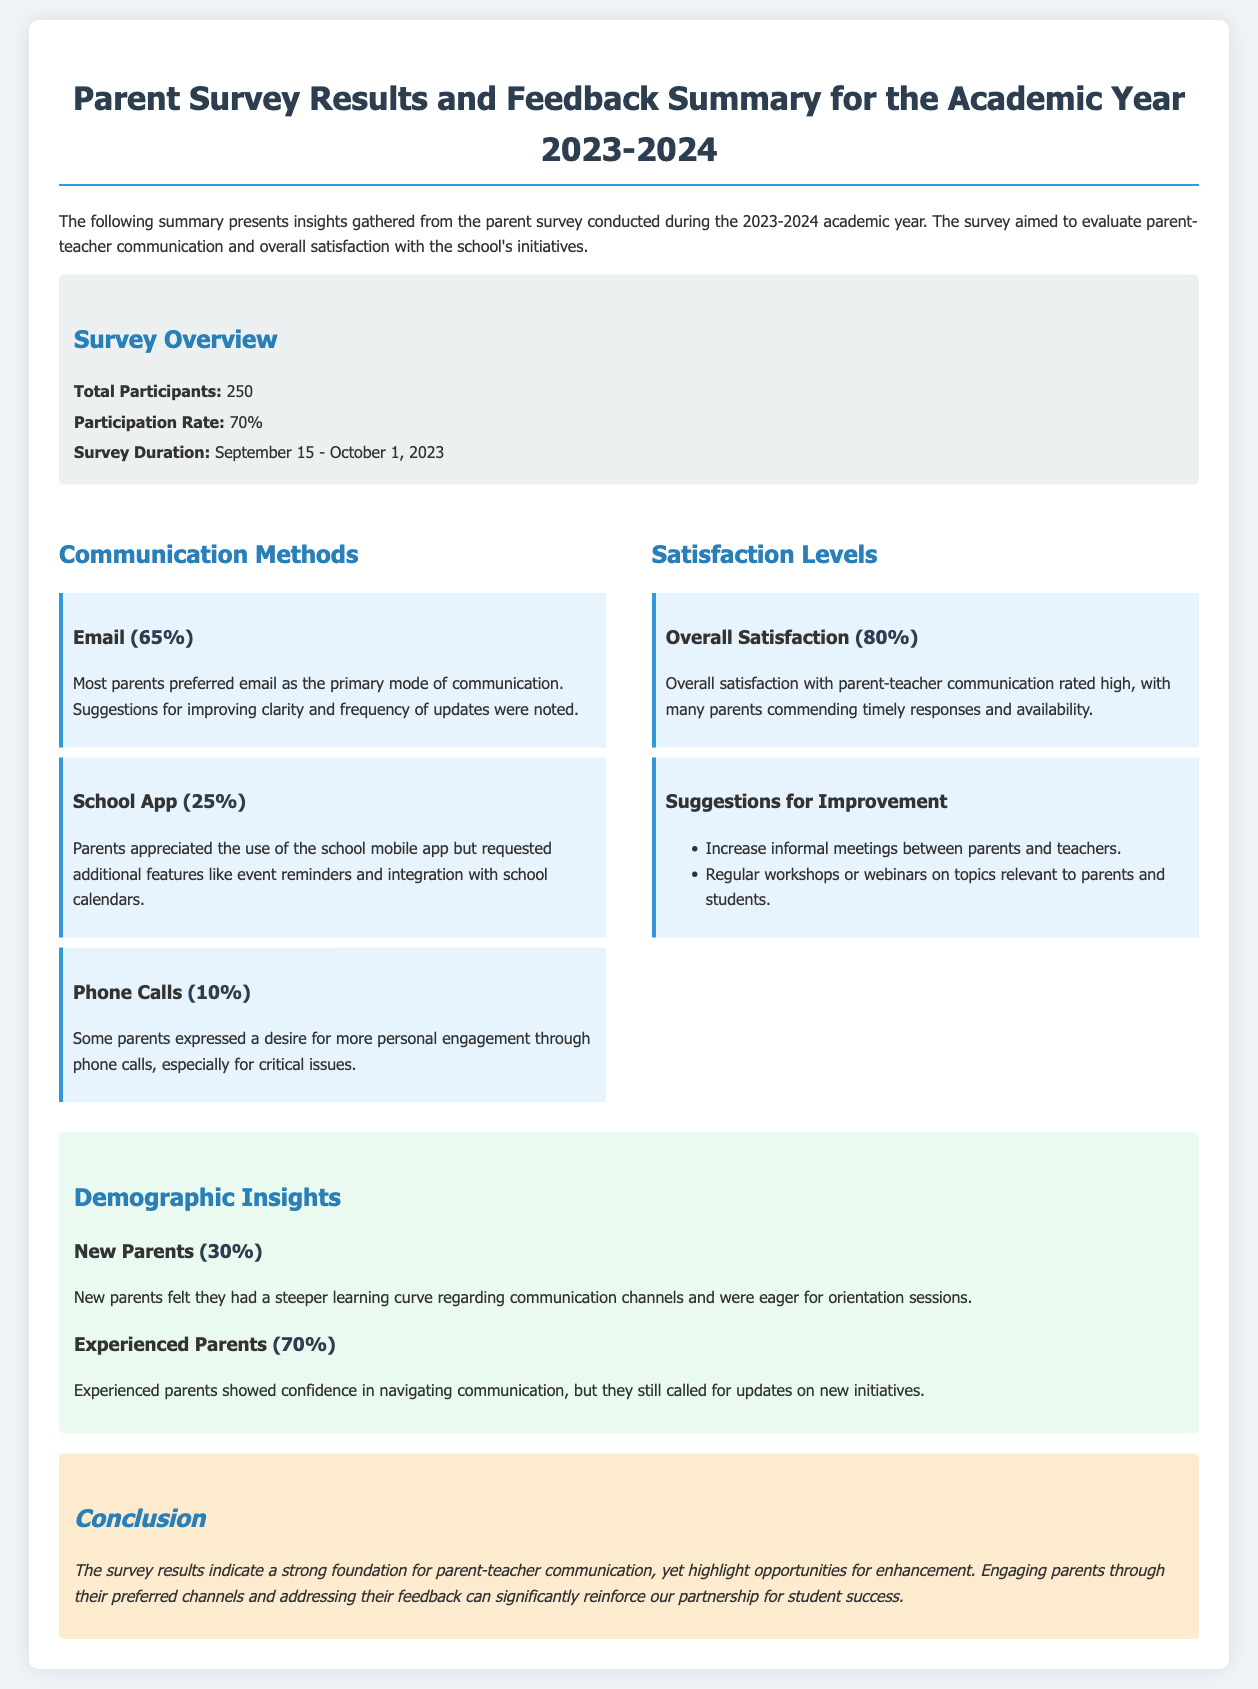What was the total number of participants in the survey? The total number of participants is mentioned in the survey overview section, which states 250.
Answer: 250 What percentage of parents preferred email as the communication method? The document notes that 65% of parents preferred email according to the communication methods section.
Answer: 65% What was the participation rate of the survey? The participation rate is also in the survey overview and is stated as 70%.
Answer: 70% What percentage of parents expressed overall satisfaction with communication? The satisfaction levels section highlights that overall satisfaction rated high at 80%.
Answer: 80% What suggestion was made for improving communication? A suggestion for improvement that stood out was to increase informal meetings between parents and teachers, listed under suggestions for improvement.
Answer: Increase informal meetings What demographic percentage represents new parents in the survey results? The demographic insights indicate that new parents make up 30% of the respondents.
Answer: 30% Which communication method received the least preference? The communication methods section indicates that phone calls were the least preferred, cited at 10%.
Answer: Phone Calls What did experienced parents express a need for? Experienced parents called for updates on new initiatives as highlighted in the demographic insights section.
Answer: Updates on new initiatives What was the duration of the survey? The survey duration is listed in the overview as spanning from September 15 to October 1, 2023.
Answer: September 15 - October 1, 2023 